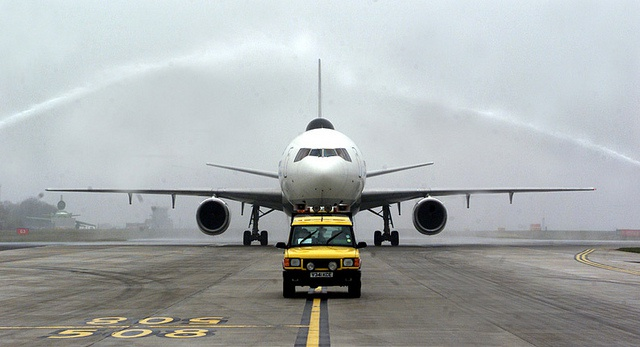Describe the objects in this image and their specific colors. I can see airplane in lightgray, black, gray, and darkgray tones, truck in lightgray, black, gray, khaki, and orange tones, and people in lightgray, black, purple, and gray tones in this image. 